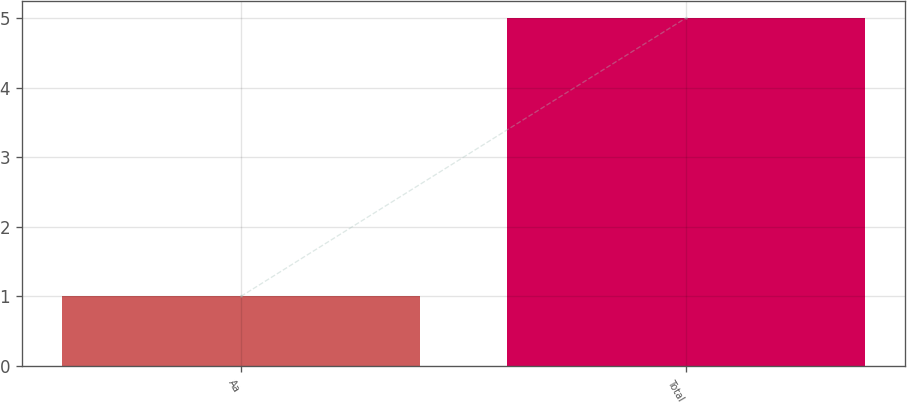<chart> <loc_0><loc_0><loc_500><loc_500><bar_chart><fcel>Aa<fcel>Total<nl><fcel>1<fcel>5<nl></chart> 